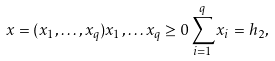Convert formula to latex. <formula><loc_0><loc_0><loc_500><loc_500>x = ( x _ { 1 } , \dots , x _ { q } ) x _ { 1 } , \dots x _ { q } \geq 0 \sum _ { i = 1 } ^ { q } x _ { i } = h _ { 2 } ,</formula> 